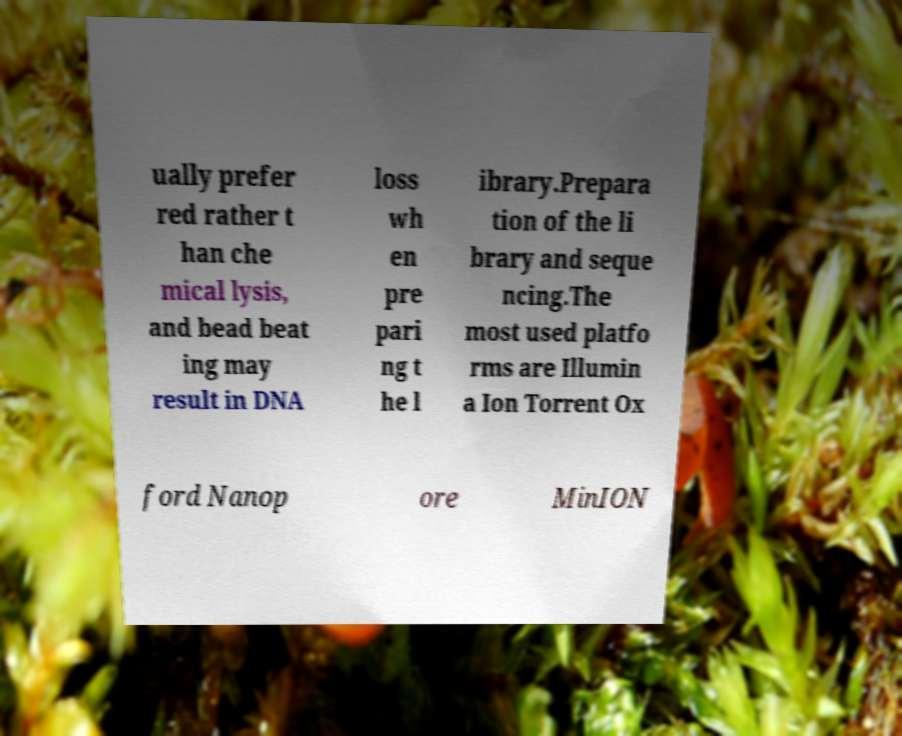Please read and relay the text visible in this image. What does it say? ually prefer red rather t han che mical lysis, and bead beat ing may result in DNA loss wh en pre pari ng t he l ibrary.Prepara tion of the li brary and seque ncing.The most used platfo rms are Illumin a Ion Torrent Ox ford Nanop ore MinION 